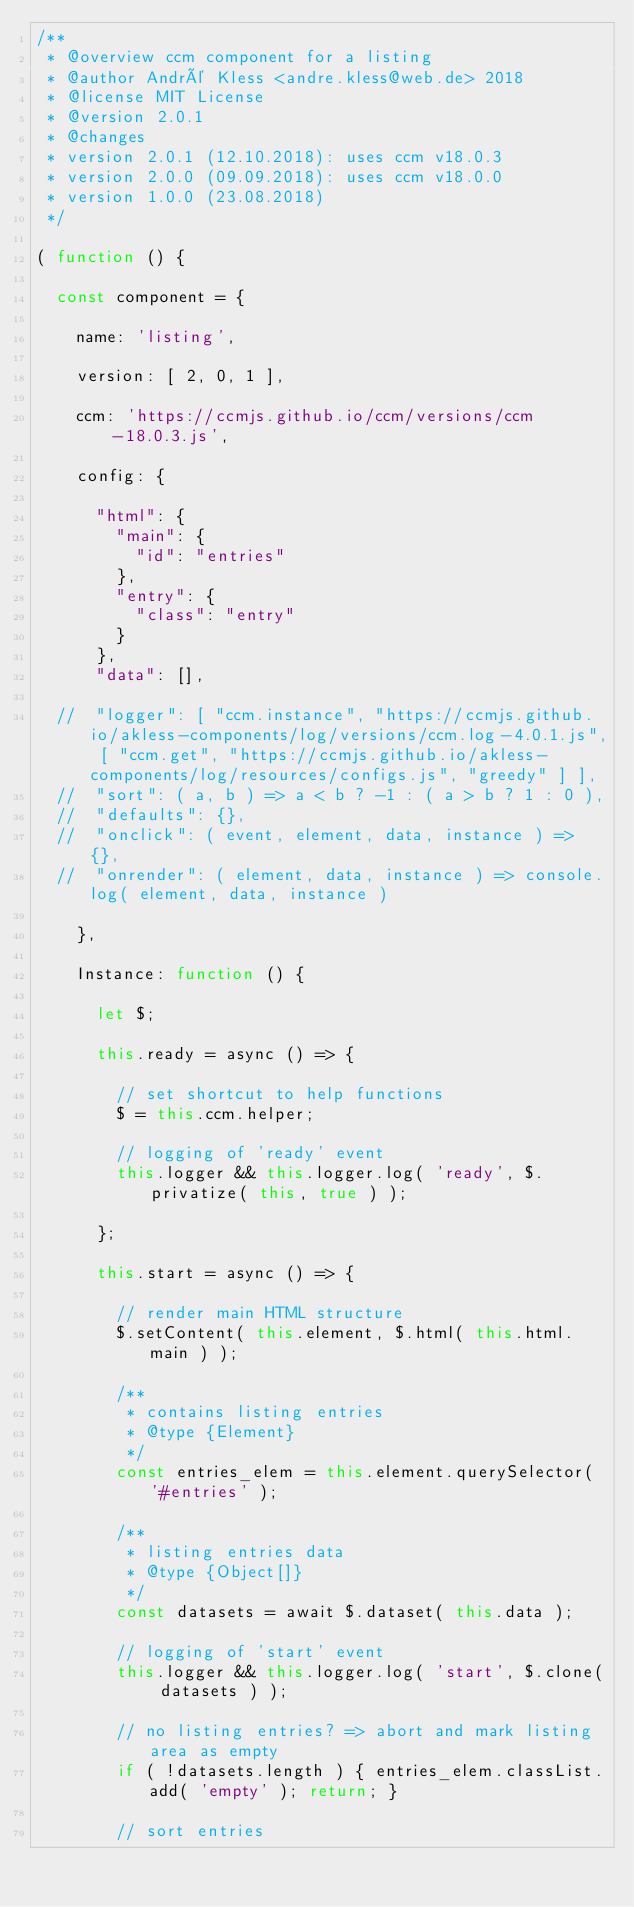Convert code to text. <code><loc_0><loc_0><loc_500><loc_500><_JavaScript_>/**
 * @overview ccm component for a listing
 * @author André Kless <andre.kless@web.de> 2018
 * @license MIT License
 * @version 2.0.1
 * @changes
 * version 2.0.1 (12.10.2018): uses ccm v18.0.3
 * version 2.0.0 (09.09.2018): uses ccm v18.0.0
 * version 1.0.0 (23.08.2018)
 */

( function () {

  const component = {

    name: 'listing',

    version: [ 2, 0, 1 ],

    ccm: 'https://ccmjs.github.io/ccm/versions/ccm-18.0.3.js',

    config: {

      "html": {
        "main": {
          "id": "entries"
        },
        "entry": {
          "class": "entry"
        }
      },
      "data": [],

  //  "logger": [ "ccm.instance", "https://ccmjs.github.io/akless-components/log/versions/ccm.log-4.0.1.js", [ "ccm.get", "https://ccmjs.github.io/akless-components/log/resources/configs.js", "greedy" ] ],
  //  "sort": ( a, b ) => a < b ? -1 : ( a > b ? 1 : 0 ),
  //  "defaults": {},
  //  "onclick": ( event, element, data, instance ) => {},
  //  "onrender": ( element, data, instance ) => console.log( element, data, instance )

    },

    Instance: function () {

      let $;

      this.ready = async () => {

        // set shortcut to help functions
        $ = this.ccm.helper;

        // logging of 'ready' event
        this.logger && this.logger.log( 'ready', $.privatize( this, true ) );

      };

      this.start = async () => {

        // render main HTML structure
        $.setContent( this.element, $.html( this.html.main ) );

        /**
         * contains listing entries
         * @type {Element}
         */
        const entries_elem = this.element.querySelector( '#entries' );

        /**
         * listing entries data
         * @type {Object[]}
         */
        const datasets = await $.dataset( this.data );

        // logging of 'start' event
        this.logger && this.logger.log( 'start', $.clone( datasets ) );

        // no listing entries? => abort and mark listing area as empty
        if ( !datasets.length ) { entries_elem.classList.add( 'empty' ); return; }

        // sort entries</code> 